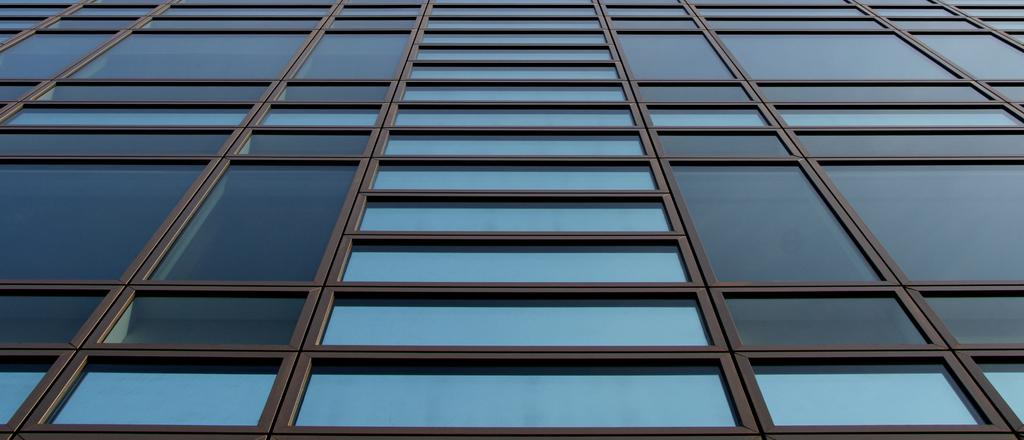What type of structure is visible in the image? There is a building in the image. What materials are used in the construction of the building? The building has glass elements and iron rods. What type of skin condition can be seen on the building in the image? There is no skin condition present on the building in the image, as buildings do not have skin. 